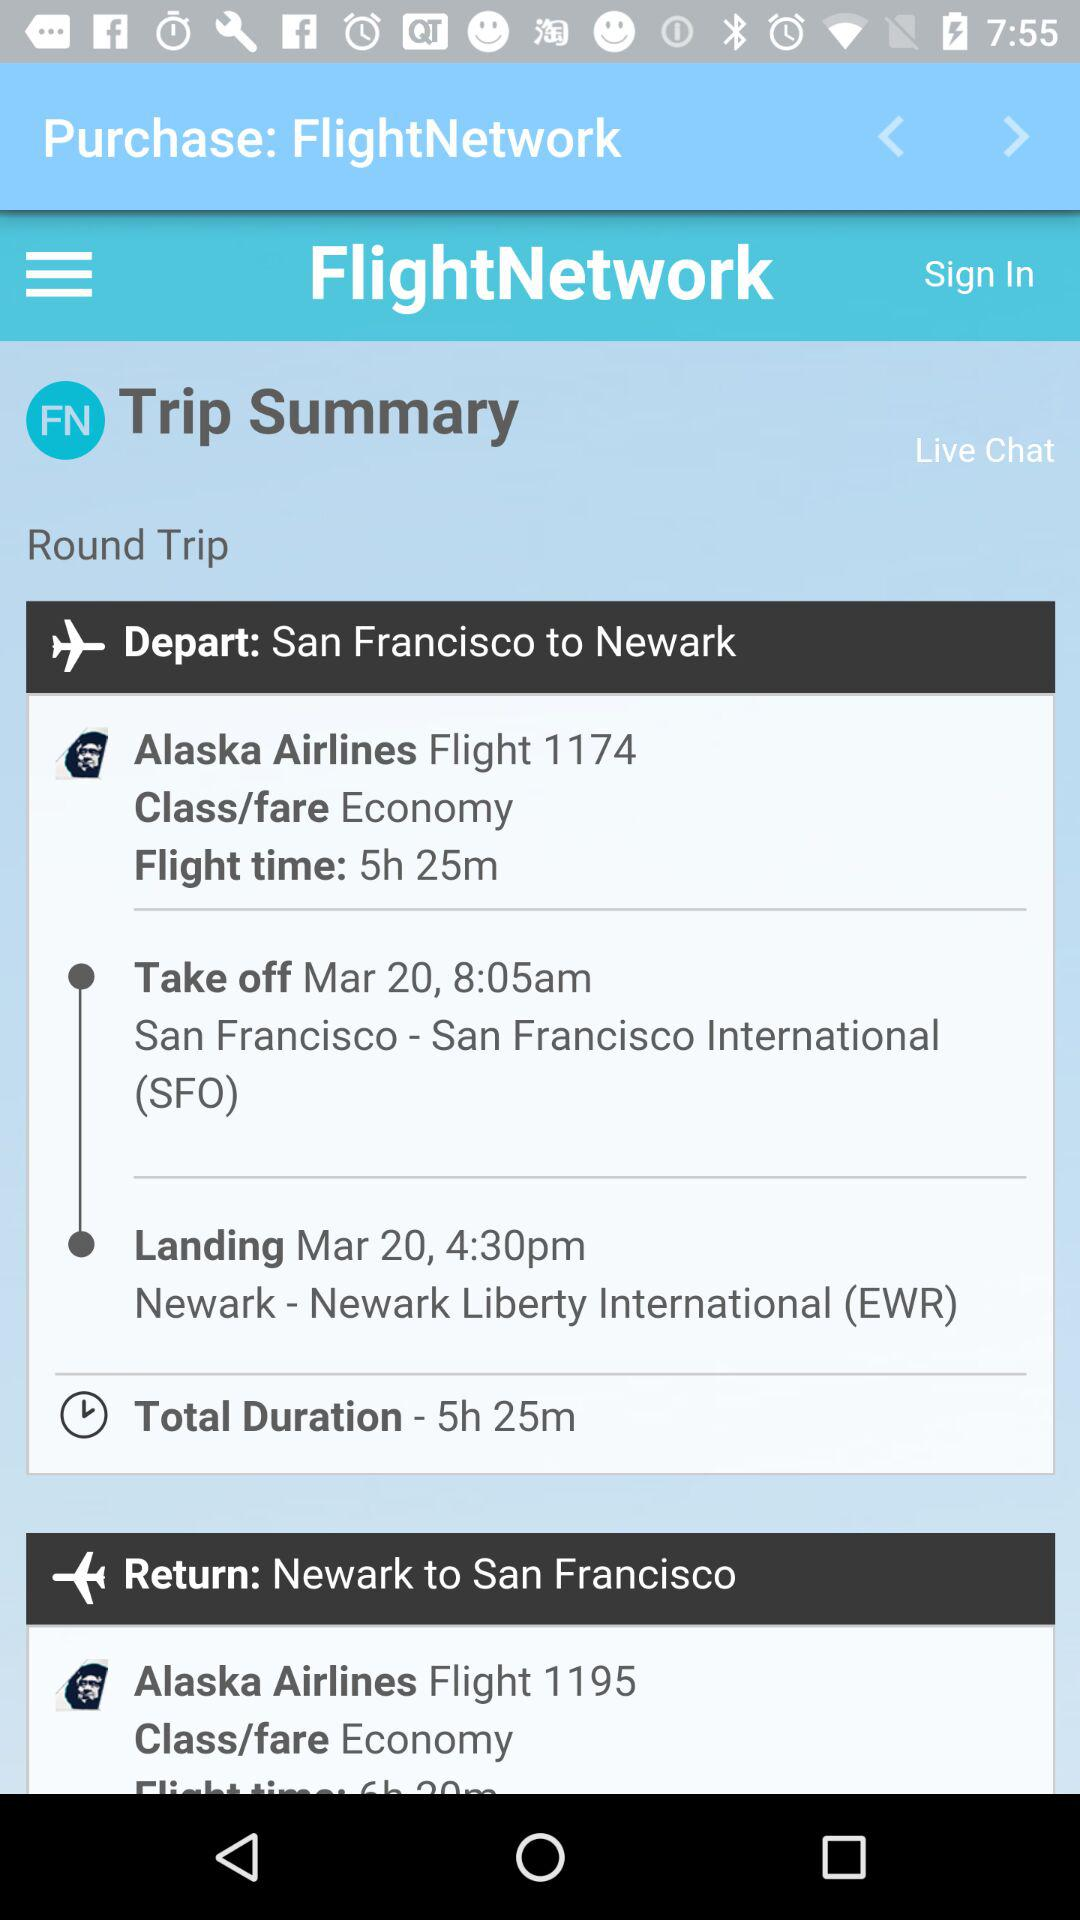What is the selected class for the flight from San Francisco to Newark? The selected class is economy. 